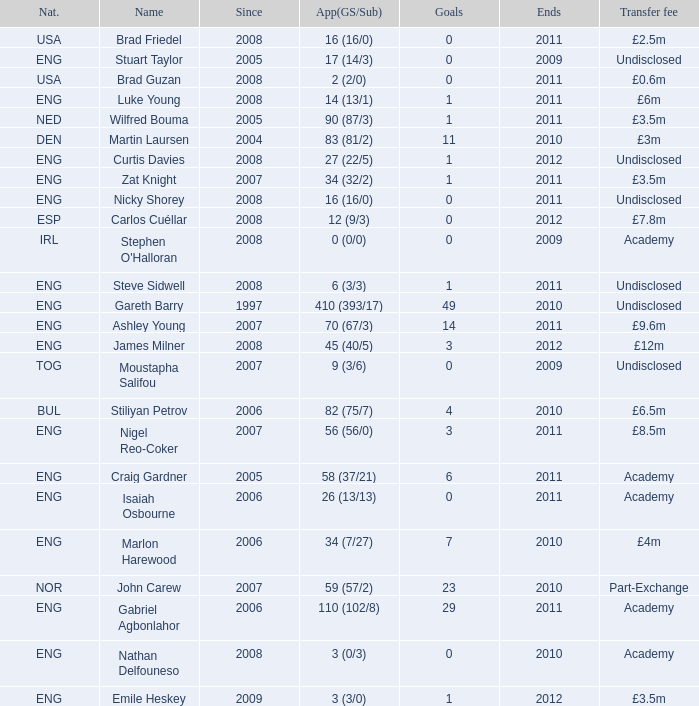When the transfer fee is £8.5m, what is the total ends? 2011.0. 